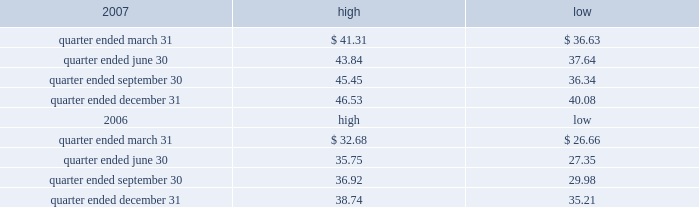Part ii item 5 .
Market for registrant 2019s common equity , related stockholder matters and issuer purchases of equity securities the table presents reported quarterly high and low per share sale prices of our class a common stock on the new york stock exchange ( 201cnyse 201d ) for the years 2007 and 2006. .
On february 29 , 2008 , the closing price of our class a common stock was $ 38.44 per share as reported on the nyse .
As of february 29 , 2008 , we had 395748826 outstanding shares of class a common stock and 528 registered holders .
Dividends we have never paid a dividend on any class of our common stock .
We anticipate that we may retain future earnings , if any , to fund the development and growth of our business .
The indentures governing our 7.50% ( 7.50 % ) senior notes due 2012 ( 201c7.50% ( 201c7.50 % ) notes 201d ) and our 7.125% ( 7.125 % ) senior notes due 2012 ( 201c7.125% ( 201c7.125 % ) notes 201d ) may prohibit us from paying dividends to our stockholders unless we satisfy certain financial covenants .
The loan agreement for our revolving credit facility and the indentures governing the terms of our 7.50% ( 7.50 % ) notes and 7.125% ( 7.125 % ) notes contain covenants that restrict our ability to pay dividends unless certain financial covenants are satisfied .
In addition , while spectrasite and its subsidiaries are classified as unrestricted subsidiaries under the indentures for our 7.50% ( 7.50 % ) notes and 7.125% ( 7.125 % ) notes , certain of spectrasite 2019s subsidiaries are subject to restrictions on the amount of cash that they can distribute to us under the loan agreement related to our securitization .
For more information about the restrictions under the loan agreement for the revolving credit facility , our notes indentures and the loan agreement related to the securitization , see item 7 of this annual report under the caption 201cmanagement 2019s discussion and analysis of financial condition and results of operations 2014liquidity and capital resources 2014factors affecting sources of liquidity 201d and note 3 to our consolidated financial statements included in this annual report. .
For 2007 , what was thee average quarterly high stock price? 
Computations: ((((41.31 + 43.84) + 45.45) + 46.53) / 4)
Answer: 44.2825. 